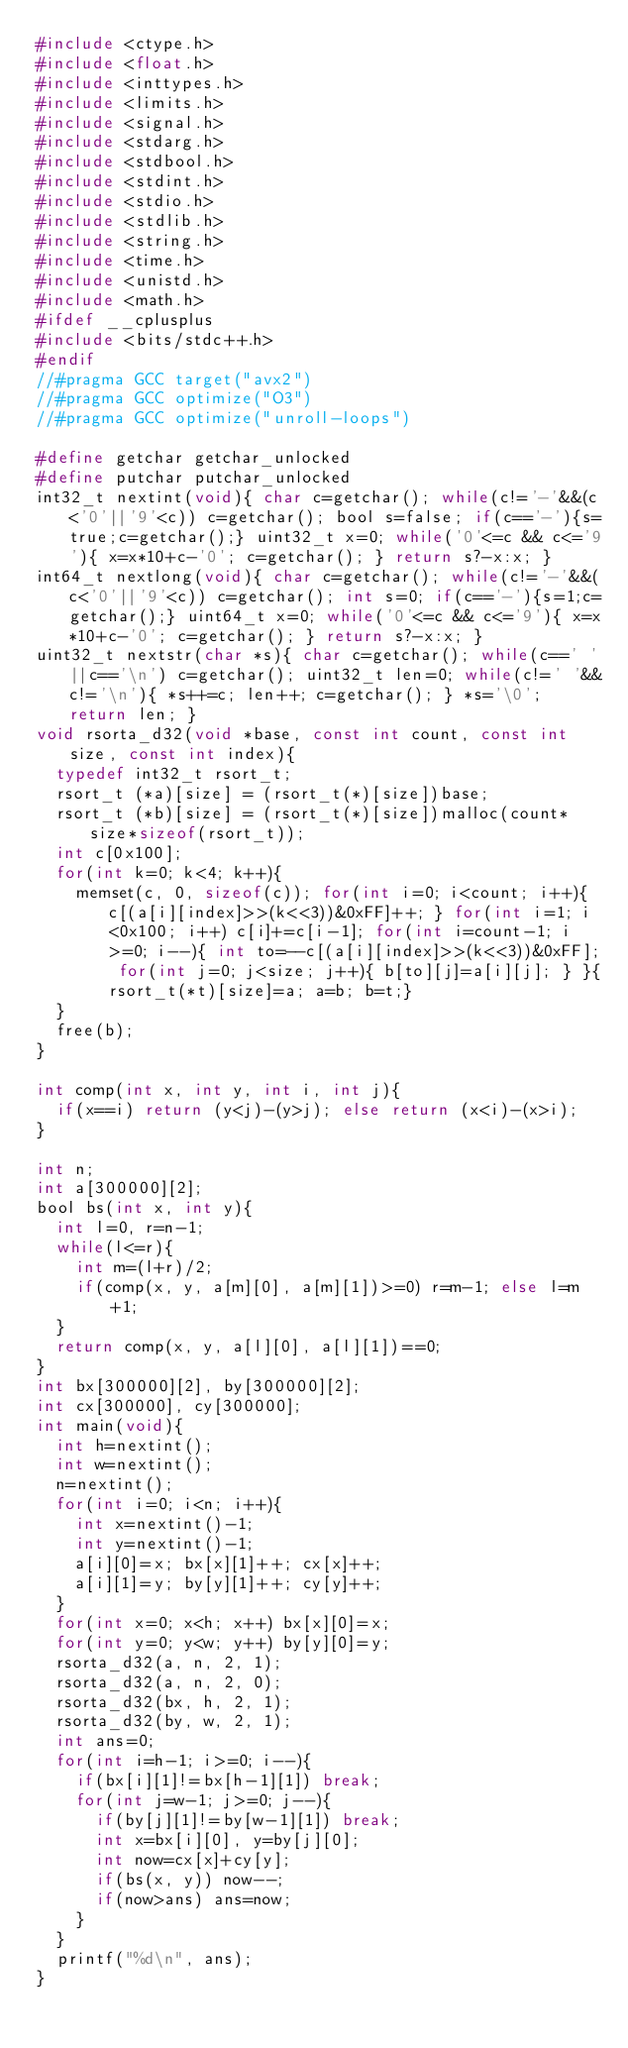<code> <loc_0><loc_0><loc_500><loc_500><_C_>#include <ctype.h>
#include <float.h>
#include <inttypes.h>
#include <limits.h>
#include <signal.h>
#include <stdarg.h>
#include <stdbool.h>
#include <stdint.h>
#include <stdio.h>
#include <stdlib.h>
#include <string.h>
#include <time.h>
#include <unistd.h>
#include <math.h>
#ifdef __cplusplus
#include <bits/stdc++.h>
#endif
//#pragma GCC target("avx2")
//#pragma GCC optimize("O3")
//#pragma GCC optimize("unroll-loops")

#define getchar getchar_unlocked
#define putchar putchar_unlocked
int32_t nextint(void){ char c=getchar(); while(c!='-'&&(c<'0'||'9'<c)) c=getchar(); bool s=false; if(c=='-'){s=true;c=getchar();} uint32_t x=0; while('0'<=c && c<='9'){ x=x*10+c-'0'; c=getchar(); } return s?-x:x; }
int64_t nextlong(void){ char c=getchar(); while(c!='-'&&(c<'0'||'9'<c)) c=getchar(); int s=0; if(c=='-'){s=1;c=getchar();} uint64_t x=0; while('0'<=c && c<='9'){ x=x*10+c-'0'; c=getchar(); } return s?-x:x; }
uint32_t nextstr(char *s){ char c=getchar(); while(c==' '||c=='\n') c=getchar(); uint32_t len=0; while(c!=' '&&c!='\n'){ *s++=c; len++; c=getchar(); } *s='\0'; return len; }
void rsorta_d32(void *base, const int count, const int size, const int index){
	typedef int32_t rsort_t;
	rsort_t (*a)[size] = (rsort_t(*)[size])base;
	rsort_t (*b)[size] = (rsort_t(*)[size])malloc(count*size*sizeof(rsort_t));
	int c[0x100];
	for(int k=0; k<4; k++){
		memset(c, 0, sizeof(c)); for(int i=0; i<count; i++){ c[(a[i][index]>>(k<<3))&0xFF]++; } for(int i=1; i<0x100; i++) c[i]+=c[i-1]; for(int i=count-1; i>=0; i--){ int to=--c[(a[i][index]>>(k<<3))&0xFF]; for(int j=0; j<size; j++){ b[to][j]=a[i][j]; } }{rsort_t(*t)[size]=a; a=b; b=t;}
	}
	free(b);
}

int comp(int x, int y, int i, int j){
	if(x==i) return (y<j)-(y>j); else return (x<i)-(x>i);
}

int n;
int a[300000][2];
bool bs(int x, int y){
	int l=0, r=n-1;
	while(l<=r){
		int m=(l+r)/2;
		if(comp(x, y, a[m][0], a[m][1])>=0) r=m-1; else l=m+1;
	}
	return comp(x, y, a[l][0], a[l][1])==0;
}
int bx[300000][2], by[300000][2];
int cx[300000], cy[300000];
int main(void){
	int h=nextint();
	int w=nextint();
	n=nextint();
	for(int i=0; i<n; i++){
		int x=nextint()-1;
		int y=nextint()-1;
		a[i][0]=x; bx[x][1]++; cx[x]++;
		a[i][1]=y; by[y][1]++; cy[y]++;
	}
	for(int x=0; x<h; x++) bx[x][0]=x;
	for(int y=0; y<w; y++) by[y][0]=y;
	rsorta_d32(a, n, 2, 1);
	rsorta_d32(a, n, 2, 0);
	rsorta_d32(bx, h, 2, 1);
	rsorta_d32(by, w, 2, 1);
	int ans=0;
	for(int i=h-1; i>=0; i--){
		if(bx[i][1]!=bx[h-1][1]) break;
		for(int j=w-1; j>=0; j--){
			if(by[j][1]!=by[w-1][1]) break;
			int x=bx[i][0], y=by[j][0];
			int now=cx[x]+cy[y];
			if(bs(x, y)) now--;
			if(now>ans) ans=now;
		}
	}
	printf("%d\n", ans);
}
</code> 